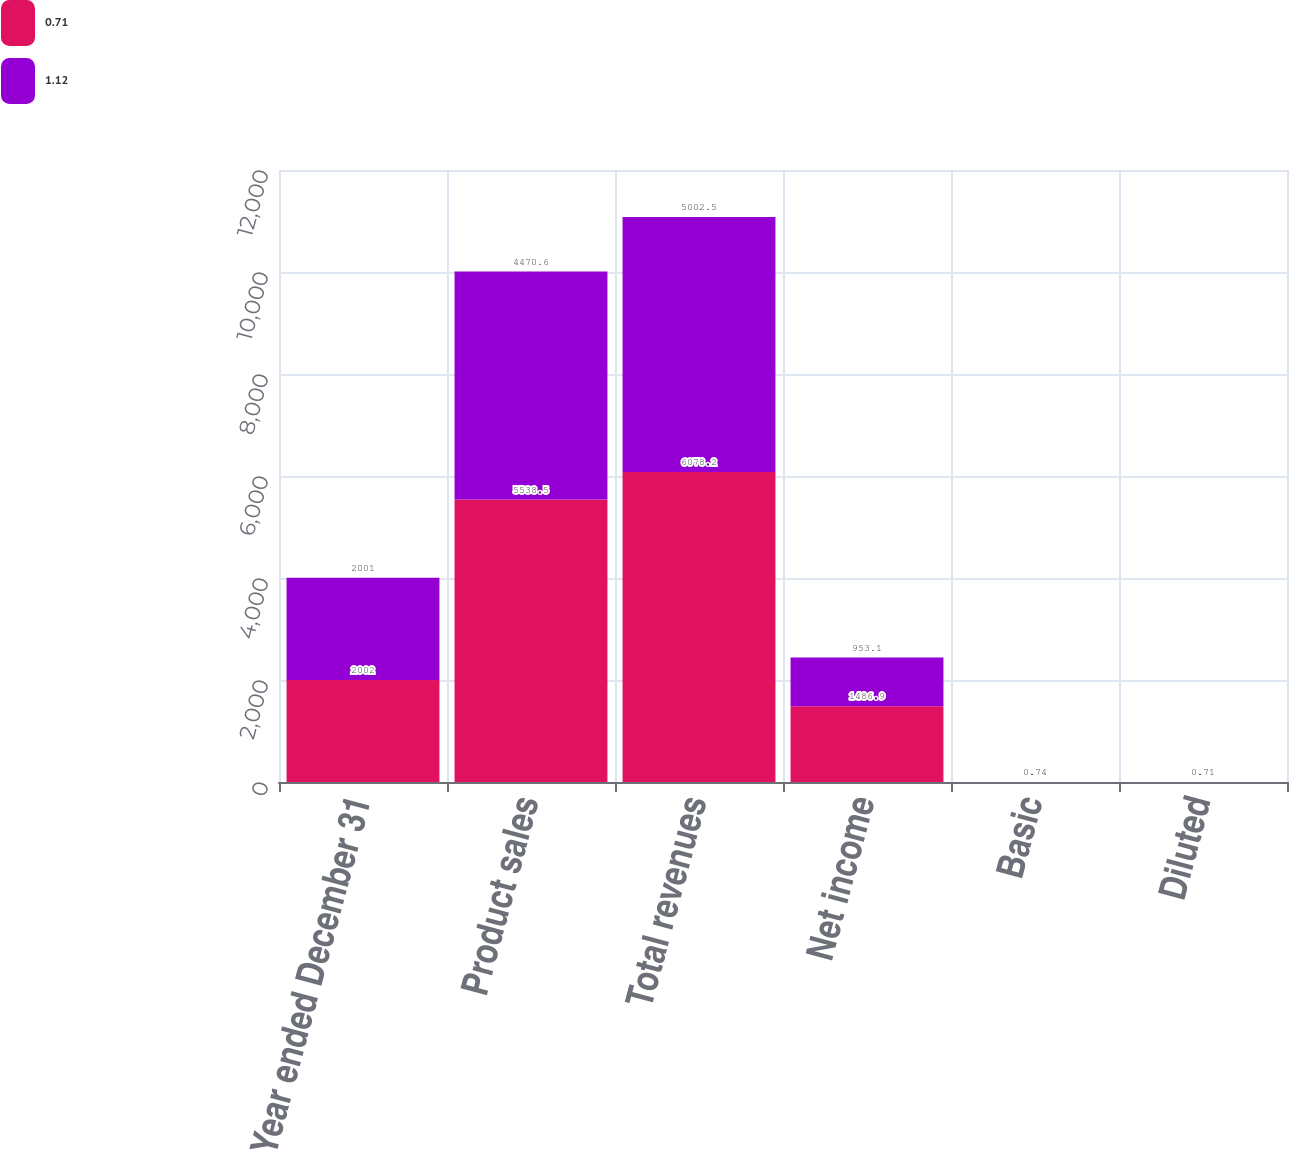Convert chart. <chart><loc_0><loc_0><loc_500><loc_500><stacked_bar_chart><ecel><fcel>Year ended December 31<fcel>Product sales<fcel>Total revenues<fcel>Net income<fcel>Basic<fcel>Diluted<nl><fcel>0.71<fcel>2002<fcel>5538.5<fcel>6078.2<fcel>1486.9<fcel>1.16<fcel>1.12<nl><fcel>1.12<fcel>2001<fcel>4470.6<fcel>5002.5<fcel>953.1<fcel>0.74<fcel>0.71<nl></chart> 